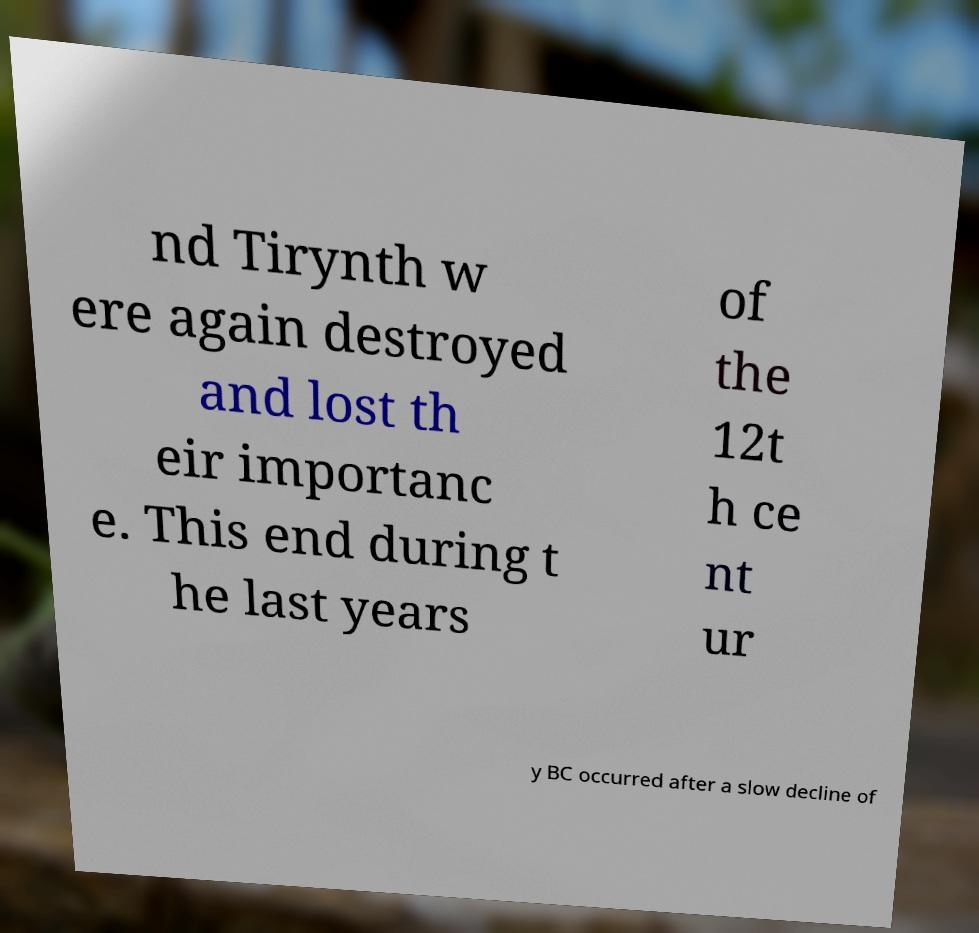Please read and relay the text visible in this image. What does it say? nd Tirynth w ere again destroyed and lost th eir importanc e. This end during t he last years of the 12t h ce nt ur y BC occurred after a slow decline of 